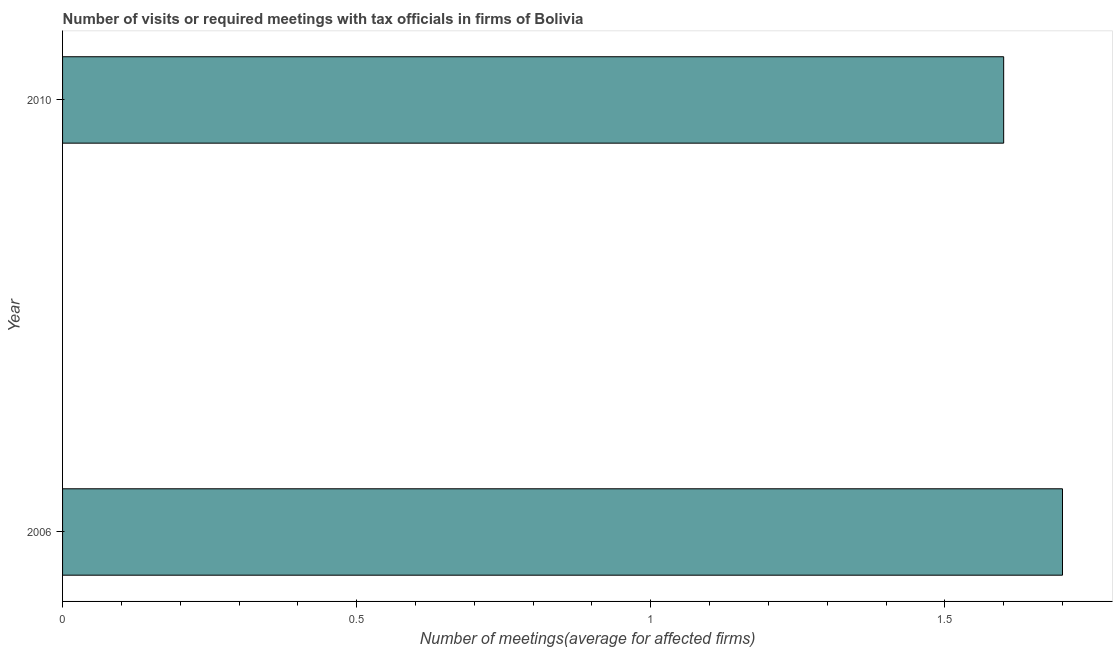Does the graph contain any zero values?
Make the answer very short. No. What is the title of the graph?
Offer a very short reply. Number of visits or required meetings with tax officials in firms of Bolivia. What is the label or title of the X-axis?
Your response must be concise. Number of meetings(average for affected firms). What is the label or title of the Y-axis?
Your answer should be compact. Year. What is the number of required meetings with tax officials in 2006?
Ensure brevity in your answer.  1.7. What is the average number of required meetings with tax officials per year?
Ensure brevity in your answer.  1.65. What is the median number of required meetings with tax officials?
Keep it short and to the point. 1.65. In how many years, is the number of required meetings with tax officials greater than 0.8 ?
Your response must be concise. 2. What is the ratio of the number of required meetings with tax officials in 2006 to that in 2010?
Offer a very short reply. 1.06. In how many years, is the number of required meetings with tax officials greater than the average number of required meetings with tax officials taken over all years?
Give a very brief answer. 1. How many bars are there?
Make the answer very short. 2. What is the difference between the Number of meetings(average for affected firms) in 2006 and 2010?
Your response must be concise. 0.1. What is the ratio of the Number of meetings(average for affected firms) in 2006 to that in 2010?
Your answer should be very brief. 1.06. 